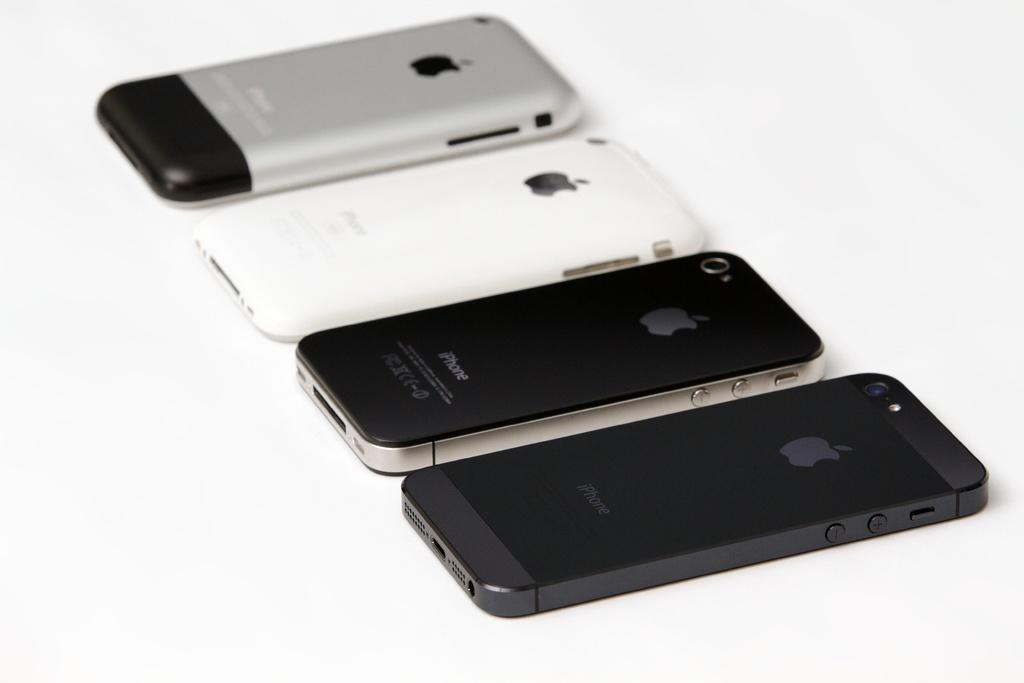<image>
Offer a succinct explanation of the picture presented. Four different iPhones are laid out next to each other. 